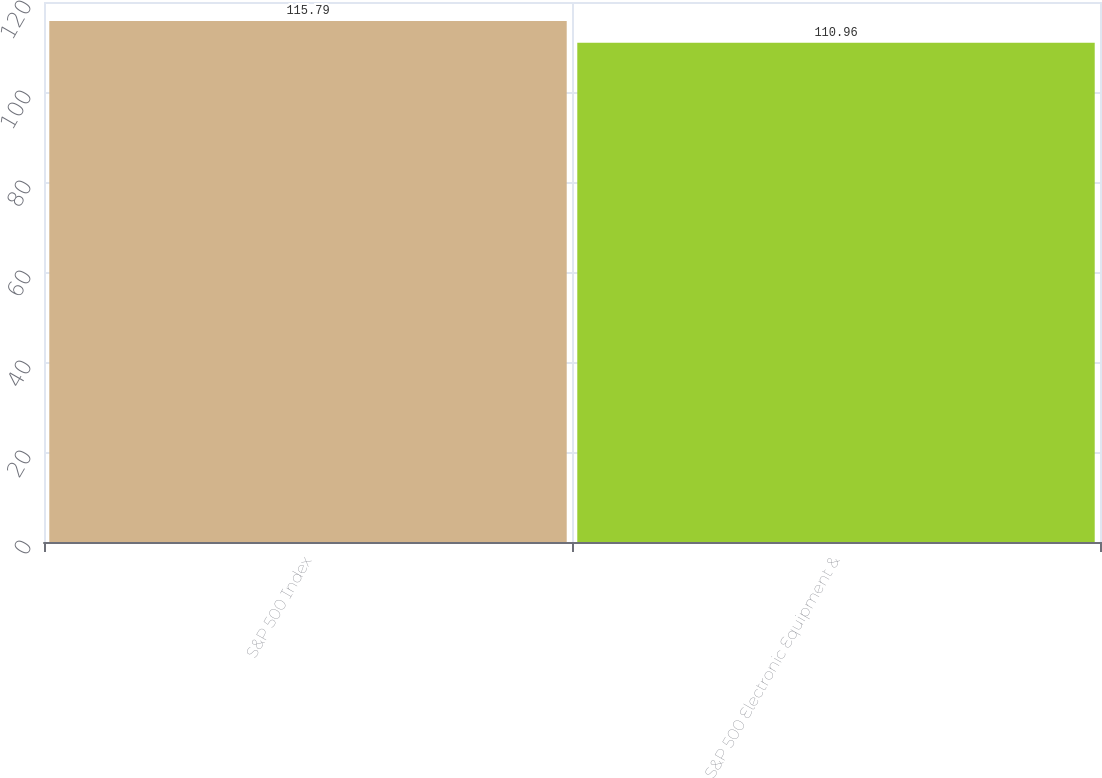Convert chart. <chart><loc_0><loc_0><loc_500><loc_500><bar_chart><fcel>S&P 500 Index<fcel>S&P 500 Electronic Equipment &<nl><fcel>115.79<fcel>110.96<nl></chart> 